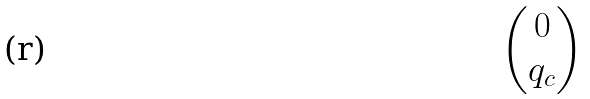<formula> <loc_0><loc_0><loc_500><loc_500>\begin{pmatrix} 0 \\ q _ { c } \end{pmatrix}</formula> 